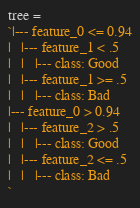Convert code to text. <code><loc_0><loc_0><loc_500><loc_500><_JavaScript_>tree = 
`|--- feature_0 <= 0.94
|   |--- feature_1 < .5
|   |   |--- class: Good
|   |--- feature_1 >= .5
|   |   |--- class: Bad
|--- feature_0 > 0.94
|   |--- feature_2 > .5
|   |   |--- class: Good
|   |--- feature_2 <= .5
|   |   |--- class: Bad
`</code> 